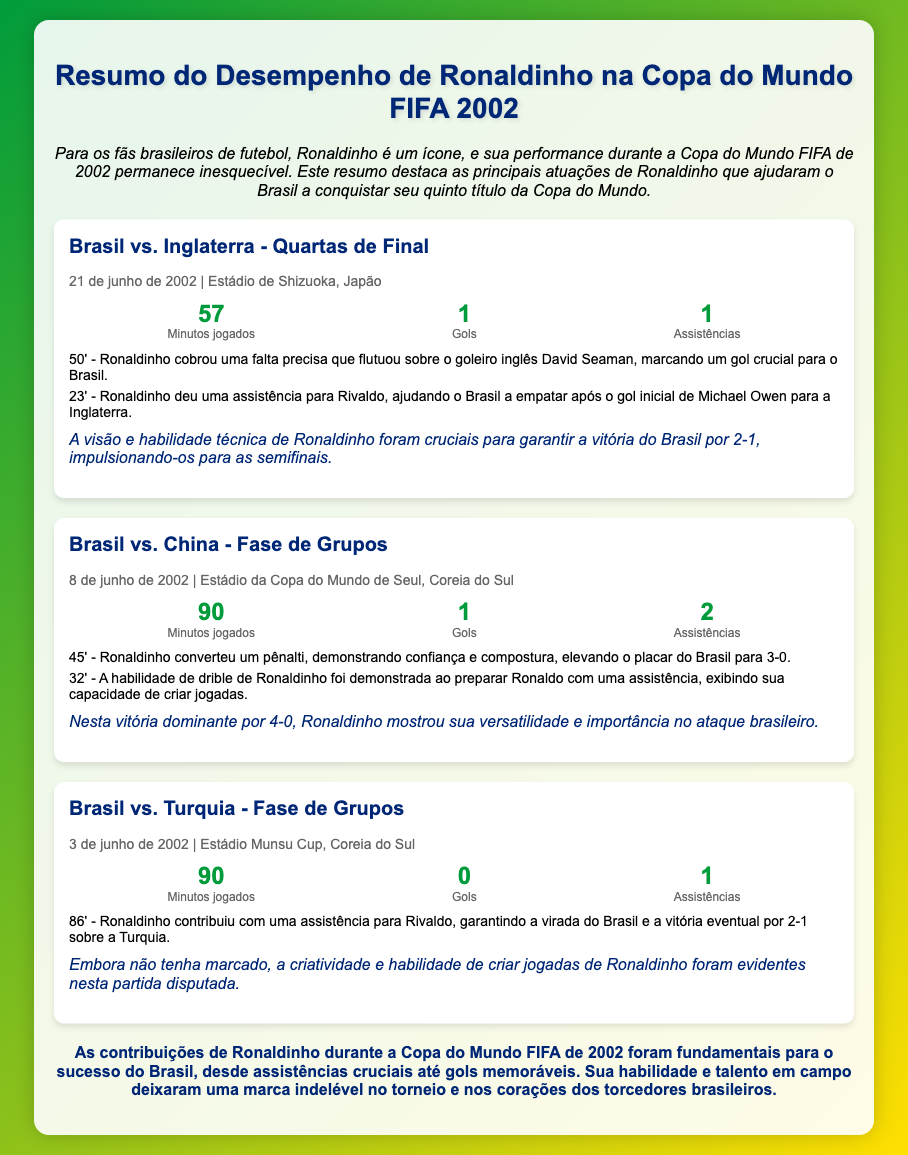qual foi a data do jogo Brasil vs. Inglaterra? A data do jogo Brasil vs. Inglaterra foi 21 de junho de 2002.
Answer: 21 de junho de 2002 quantos gols Ronaldinho fez contra a China? Ronaldinho fez 1 gol contra a China.
Answer: 1 quantos minutos Ronaldinho jogou na partida contra a Turquia? Ronaldinho jogou 90 minutos na partida contra a Turquia.
Answer: 90 quem foi o goleiro inglês que sofreu o gol de falta de Ronaldinho? O goleiro inglês que sofreu o gol de falta foi David Seaman.
Answer: David Seaman qual foi o resultado da partida entre Brasil e China? O resultado da partida entre Brasil e China foi 4-0.
Answer: 4-0 quais foram as contribuições de Ronaldinho na partida contra a Inglaterra? Ronaldinho contribuiu com 1 gol e 1 assistência na partida contra a Inglaterra.
Answer: 1 gol e 1 assistência o que Ronaldinho fez aos 45 minutos na partida contra a China? Ronaldinho converteu um pênalti aos 45 minutos na partida contra a China.
Answer: converteu um pênalti que impacto teve a atuação de Ronaldinho na partida contra a Inglaterra? A atuação de Ronaldinho foi crucial para garantir a vitória do Brasil por 2-1.
Answer: crucial para a vitória qual foi o resultado do jogo Brasil vs. Turquia? O resultado do jogo Brasil vs. Turquia foi 2-1.
Answer: 2-1 